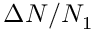<formula> <loc_0><loc_0><loc_500><loc_500>\Delta N / N _ { 1 }</formula> 